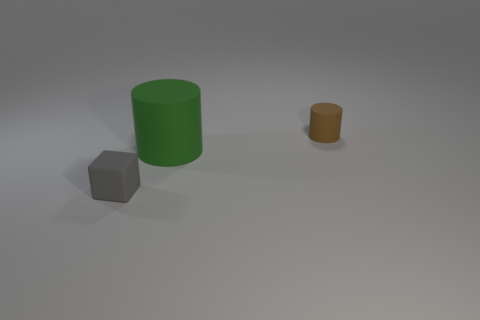Is there any other thing that has the same shape as the small gray object?
Provide a succinct answer. No. What is the color of the small object that is on the right side of the small gray thing?
Provide a short and direct response. Brown. What number of gray rubber blocks are there?
Make the answer very short. 1. There is a big green object that is the same material as the gray cube; what is its shape?
Ensure brevity in your answer.  Cylinder. There is a matte thing that is to the left of the green cylinder; does it have the same color as the cylinder that is in front of the small cylinder?
Provide a short and direct response. No. Are there the same number of small gray matte things behind the tiny gray rubber block and tiny brown matte objects?
Keep it short and to the point. No. There is a big rubber cylinder; what number of tiny cubes are behind it?
Offer a terse response. 0. How big is the gray matte thing?
Your answer should be compact. Small. What color is the big cylinder that is made of the same material as the small gray block?
Ensure brevity in your answer.  Green. How many gray rubber things have the same size as the gray matte block?
Make the answer very short. 0. 